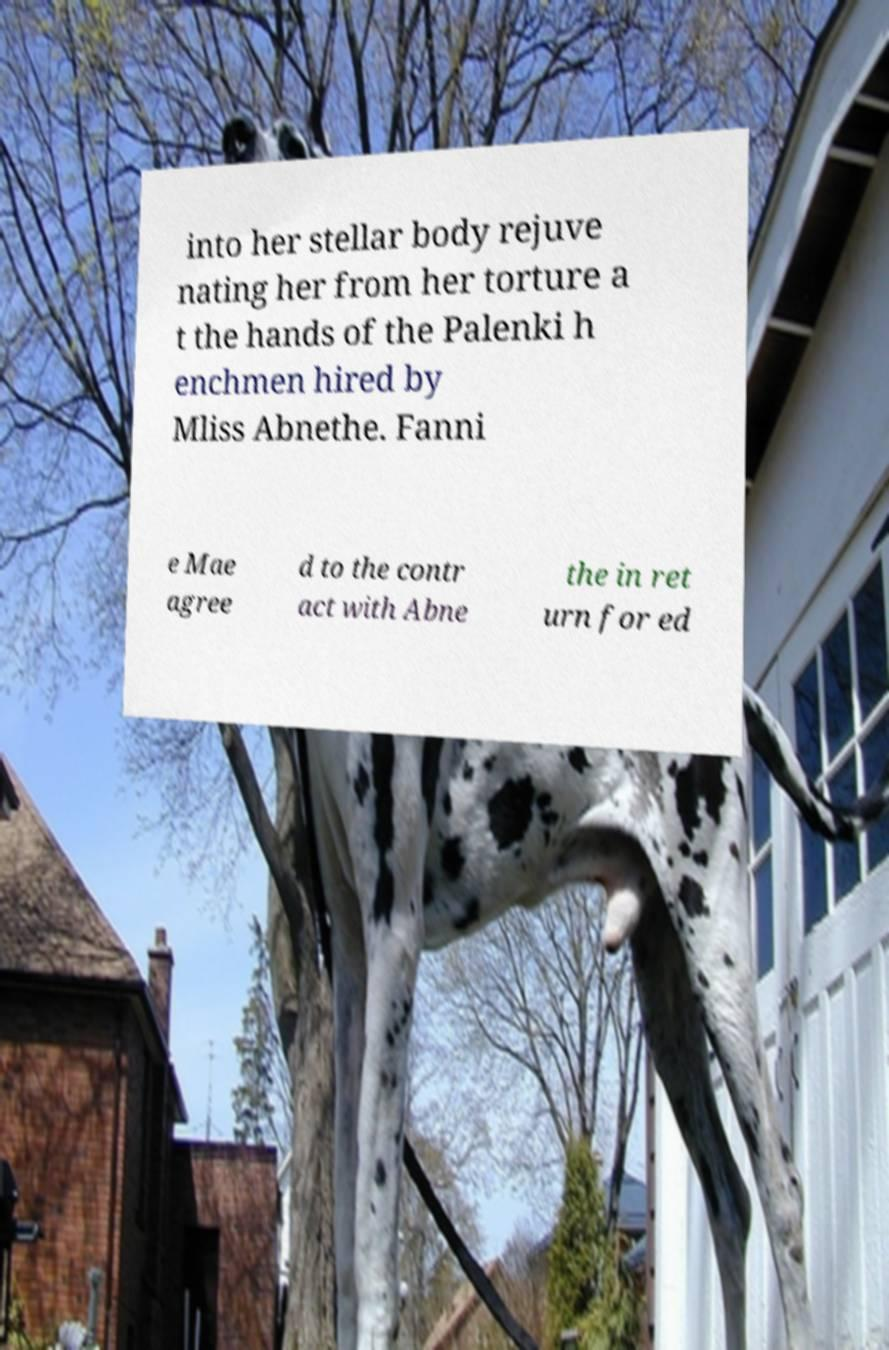There's text embedded in this image that I need extracted. Can you transcribe it verbatim? into her stellar body rejuve nating her from her torture a t the hands of the Palenki h enchmen hired by Mliss Abnethe. Fanni e Mae agree d to the contr act with Abne the in ret urn for ed 